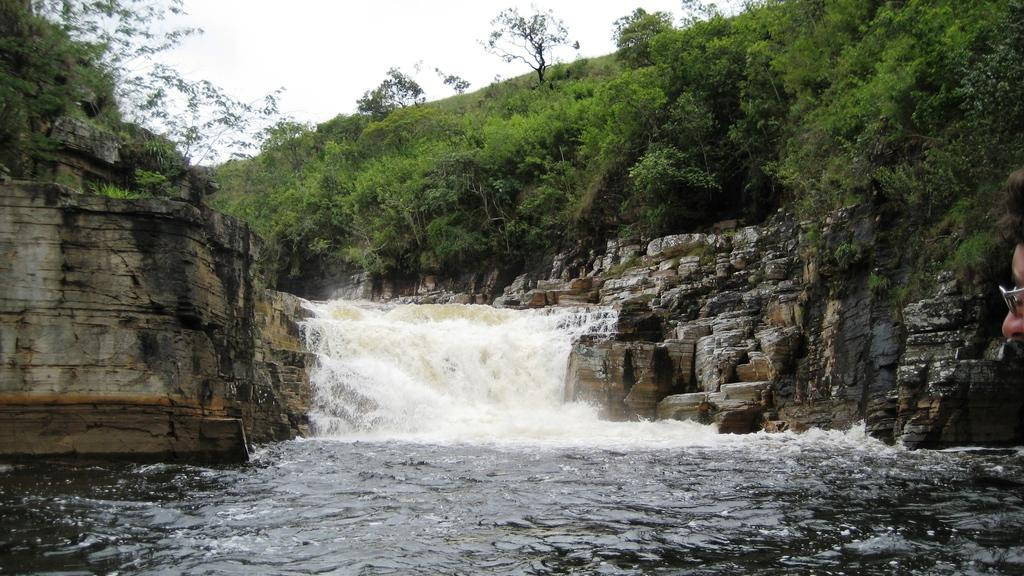What is happening in the image related to water? There is water flow in the image. What type of vegetation can be seen in the image? There are trees and plants in the image. What geographical feature is present in the image? There is a hill in the image. What part of the natural environment is visible in the image? The sky is visible in the image. What type of learning can be observed in the image? There is no learning activity present in the image; it features water flow, trees, plants, a hill, and the sky. What type of skin is visible on the trees in the image? The trees in the image do not have skin; they have bark, which is the outer protective layer of a tree. 